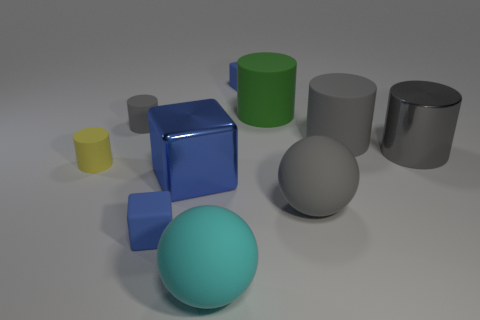Subtract all gray cubes. How many gray cylinders are left? 3 Subtract all blue matte blocks. How many blocks are left? 1 Subtract 3 cylinders. How many cylinders are left? 2 Subtract all yellow cylinders. How many cylinders are left? 4 Subtract all purple cylinders. Subtract all yellow blocks. How many cylinders are left? 5 Subtract all cubes. How many objects are left? 7 Subtract 0 cyan cylinders. How many objects are left? 10 Subtract all purple things. Subtract all large balls. How many objects are left? 8 Add 1 big spheres. How many big spheres are left? 3 Add 2 brown cubes. How many brown cubes exist? 2 